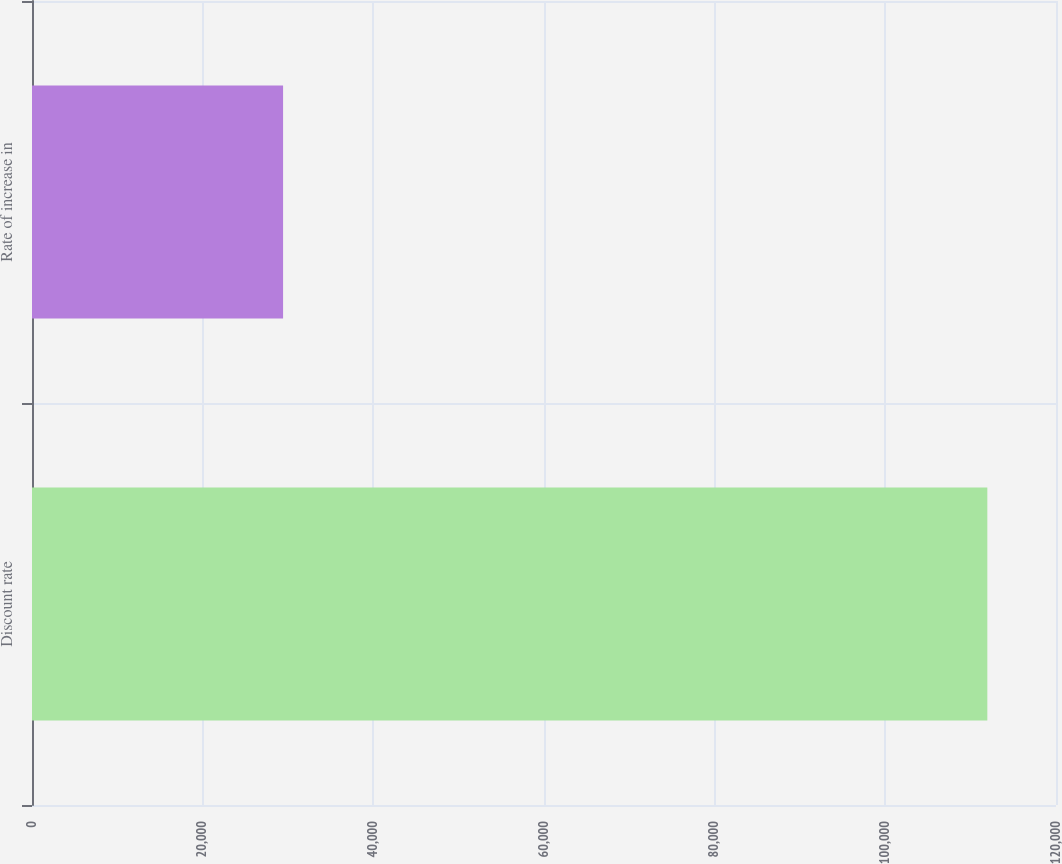Convert chart. <chart><loc_0><loc_0><loc_500><loc_500><bar_chart><fcel>Discount rate<fcel>Rate of increase in<nl><fcel>111953<fcel>29424<nl></chart> 